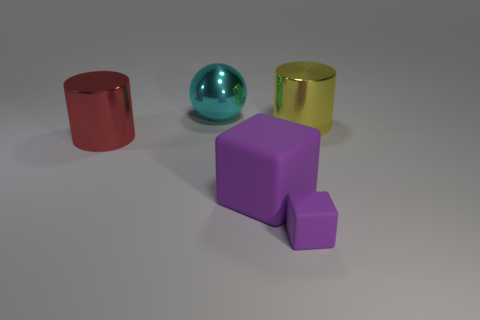Add 2 cyan spheres. How many objects exist? 7 Subtract all red cylinders. How many cylinders are left? 1 Subtract all cylinders. How many objects are left? 3 Subtract 1 blocks. How many blocks are left? 1 Add 1 large objects. How many large objects are left? 5 Add 3 big green cubes. How many big green cubes exist? 3 Subtract 0 cyan cylinders. How many objects are left? 5 Subtract all green cylinders. Subtract all red blocks. How many cylinders are left? 2 Subtract all yellow rubber cubes. Subtract all rubber objects. How many objects are left? 3 